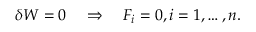Convert formula to latex. <formula><loc_0><loc_0><loc_500><loc_500>\delta W = 0 \quad \Rightarrow \quad F _ { i } = 0 , i = 1 , \dots , n .</formula> 